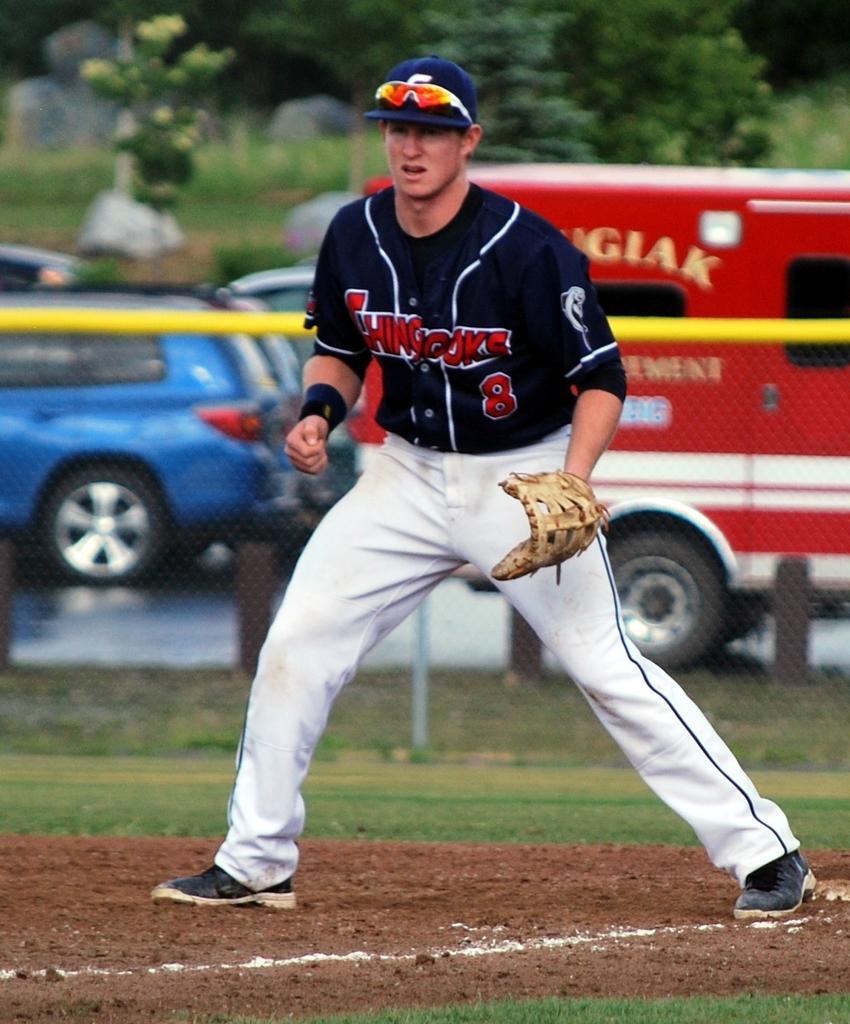Please provide a concise description of this image. In this picture we can see a person on the ground and in the background we can see vehicles, trees. 